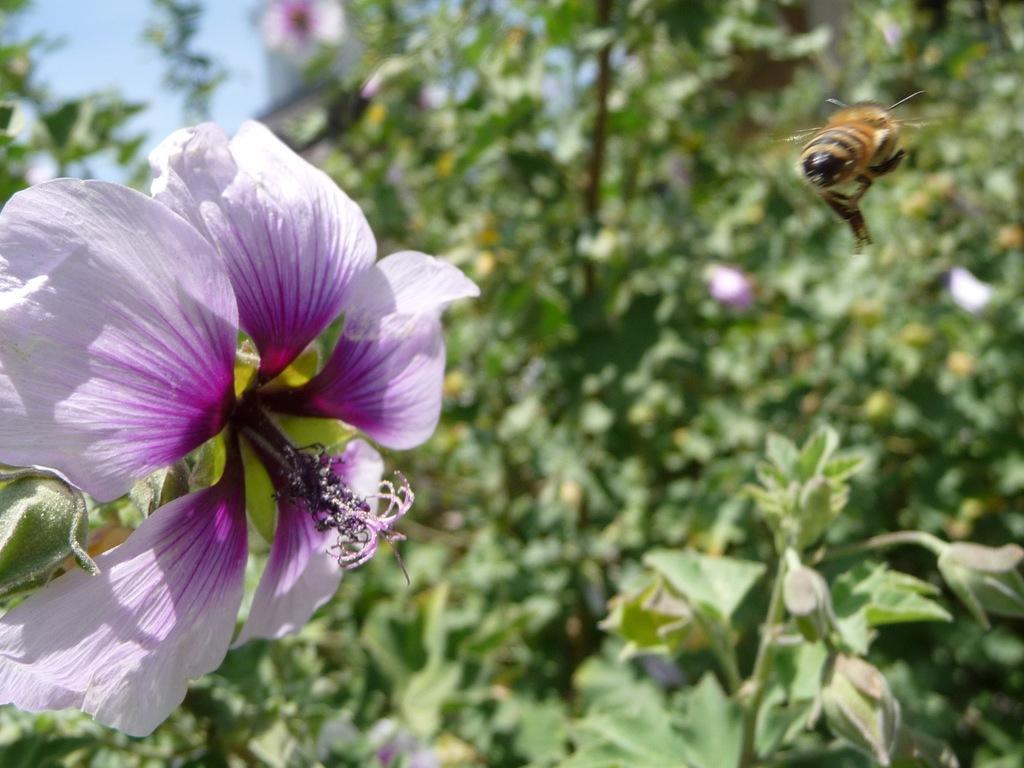Please provide a concise description of this image. This image is taken outdoors. At the top of the image there is the sky. In the background there are many trees and plants with leaves, stems and branches. On the left side of the image there is a flower, it is purple in color. On the right side of the image a honey bee is flying in the air. 